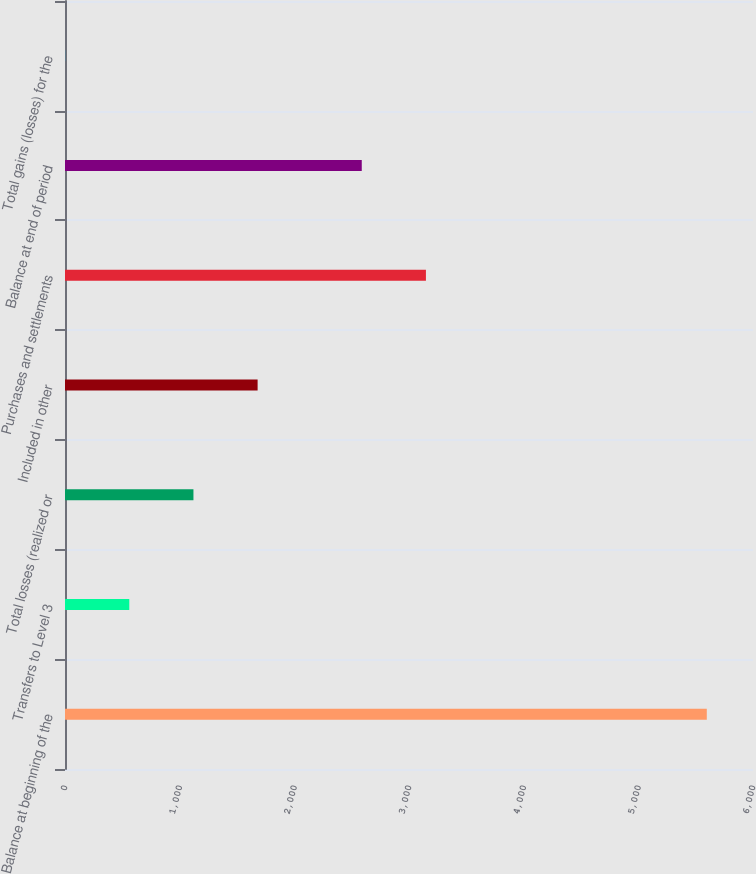Convert chart. <chart><loc_0><loc_0><loc_500><loc_500><bar_chart><fcel>Balance at beginning of the<fcel>Transfers to Level 3<fcel>Total losses (realized or<fcel>Included in other<fcel>Purchases and settlements<fcel>Balance at end of period<fcel>Total gains (losses) for the<nl><fcel>5597<fcel>560.57<fcel>1120.17<fcel>1679.77<fcel>3147.6<fcel>2588<fcel>0.97<nl></chart> 